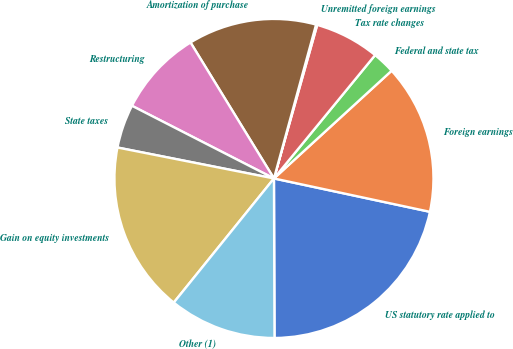<chart> <loc_0><loc_0><loc_500><loc_500><pie_chart><fcel>US statutory rate applied to<fcel>Foreign earnings<fcel>Federal and state tax<fcel>Tax rate changes<fcel>Unremitted foreign earnings<fcel>Amortization of purchase<fcel>Restructuring<fcel>State taxes<fcel>Gain on equity investments<fcel>Other (1)<nl><fcel>21.59%<fcel>15.15%<fcel>2.27%<fcel>6.56%<fcel>0.12%<fcel>13.01%<fcel>8.71%<fcel>4.42%<fcel>17.3%<fcel>10.86%<nl></chart> 